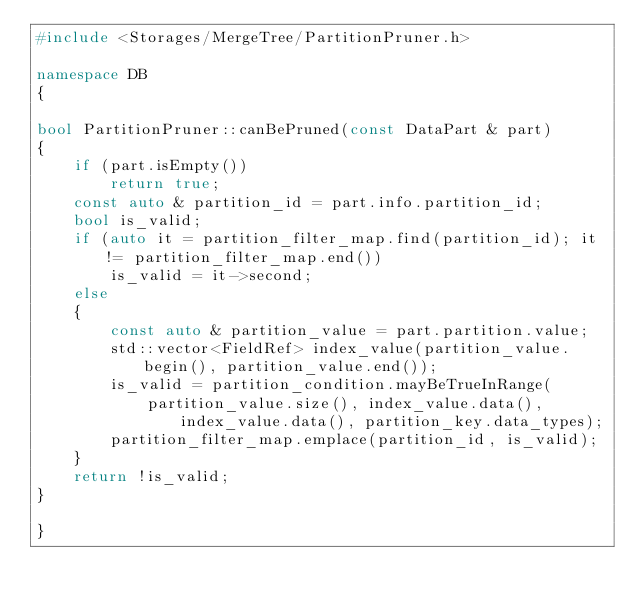<code> <loc_0><loc_0><loc_500><loc_500><_C++_>#include <Storages/MergeTree/PartitionPruner.h>

namespace DB
{

bool PartitionPruner::canBePruned(const DataPart & part)
{
    if (part.isEmpty())
        return true;
    const auto & partition_id = part.info.partition_id;
    bool is_valid;
    if (auto it = partition_filter_map.find(partition_id); it != partition_filter_map.end())
        is_valid = it->second;
    else
    {
        const auto & partition_value = part.partition.value;
        std::vector<FieldRef> index_value(partition_value.begin(), partition_value.end());
        is_valid = partition_condition.mayBeTrueInRange(
            partition_value.size(), index_value.data(), index_value.data(), partition_key.data_types);
        partition_filter_map.emplace(partition_id, is_valid);
    }
    return !is_valid;
}

}
</code> 